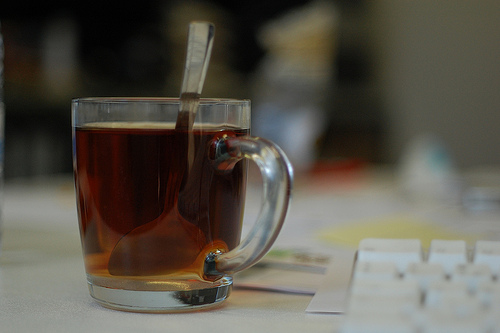<image>
Can you confirm if the spoon is behind the glass? No. The spoon is not behind the glass. From this viewpoint, the spoon appears to be positioned elsewhere in the scene. 